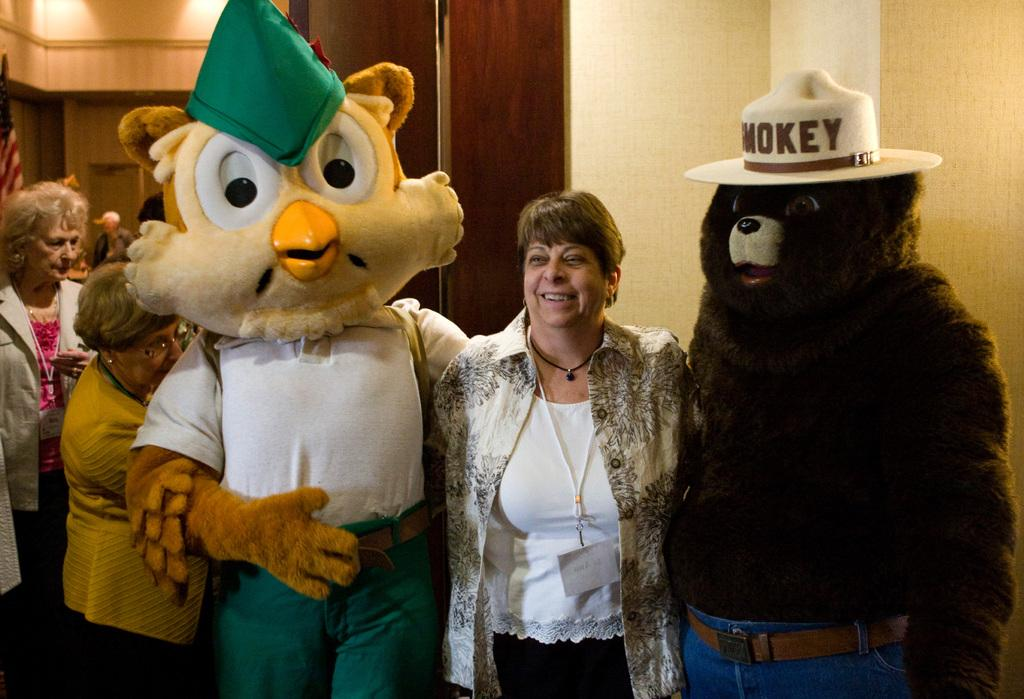How many people are in the image? There is a group of people in the image. Can you describe any specific features of the people in the image? Two of the people are wearing masks, and a woman is smiling in the image. What is visible in the background of the image? There is a wall in the background of the image. What type of property is being sold in the image? There is no property being sold in the image; it features a group of people, some of whom are wearing masks, and a woman smiling. How does the cart react to the situation in the image? There is no cart present in the image, so it cannot react to any situation. 